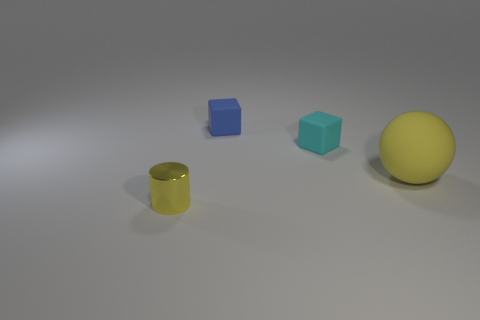Subtract all green balls. Subtract all gray cylinders. How many balls are left? 1 Add 3 tiny matte things. How many objects exist? 7 Subtract all cylinders. How many objects are left? 3 Subtract all big yellow rubber objects. Subtract all gray things. How many objects are left? 3 Add 3 large rubber balls. How many large rubber balls are left? 4 Add 1 tiny cyan matte things. How many tiny cyan matte things exist? 2 Subtract 1 yellow spheres. How many objects are left? 3 